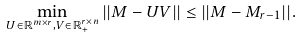Convert formula to latex. <formula><loc_0><loc_0><loc_500><loc_500>\min _ { U \in \mathbb { R } ^ { m \times r } , V \in \mathbb { R } ^ { r \times n } _ { + } } | | M - U V | | \leq | | M - M _ { r - 1 } | | .</formula> 